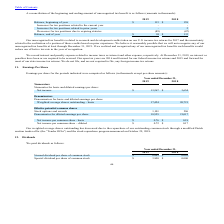According to Globalscape's financial document, Why did the company's weighted average shares outstanding decrease? due to the repurchase of our outstanding common stock through a modified Dutch auction tender offer (the “Tender Offer”) and the stock repurchase program announced on October 29, 2018.. The document states: "weighted average shares outstanding has decreased due to the repurchase of our outstanding common stock through a modified Dutch auction tender offer ..." Also, What is the basic net income per common share in 2019? According to the financial document, $0.76. The relevant text states: "Net income per common share - basic $ 0.76 $ 0.18..." Also, What is the diluted net income per common share in 2018? According to the financial document, $0.17. The relevant text states: "Net income per common share – diluted $ 0.72 $ 0.17..." Also, can you calculate: How did the company's basic weighted average shares outstanding change from 2018 to 2019? To answer this question, I need to perform calculations using the financial data. The calculation is: (17,424-20,721)/20,721, which equals -15.91 (percentage). This is based on the information: "Weighted average shares outstanding - basic 17,424 20,721 eighted average shares outstanding - basic 17,424 20,721..." The key data points involved are: 17,424, 20,721. Also, can you calculate: How did the company's Denominator for diluted earnings per share change from 2018 to 2019? To answer this question, I need to perform calculations using the financial data. The calculation is: (18,525 - 21,017)/21,017, which equals -11.86 (percentage). This is based on the information: "Denominator for diluted earnings per share 18,525 21,017 Denominator for diluted earnings per share 18,525 21,017..." The key data points involved are: 18,525, 21,017. Also, can you calculate: How much more stock options and awards did the company give out in 2019 compared to 2018? Based on the calculation: 1,101-296, the result is 805 (in thousands). This is based on the information: "Stock options and awards 1,101 296 Stock options and awards 1,101 296..." The key data points involved are: 1,101, 296. 